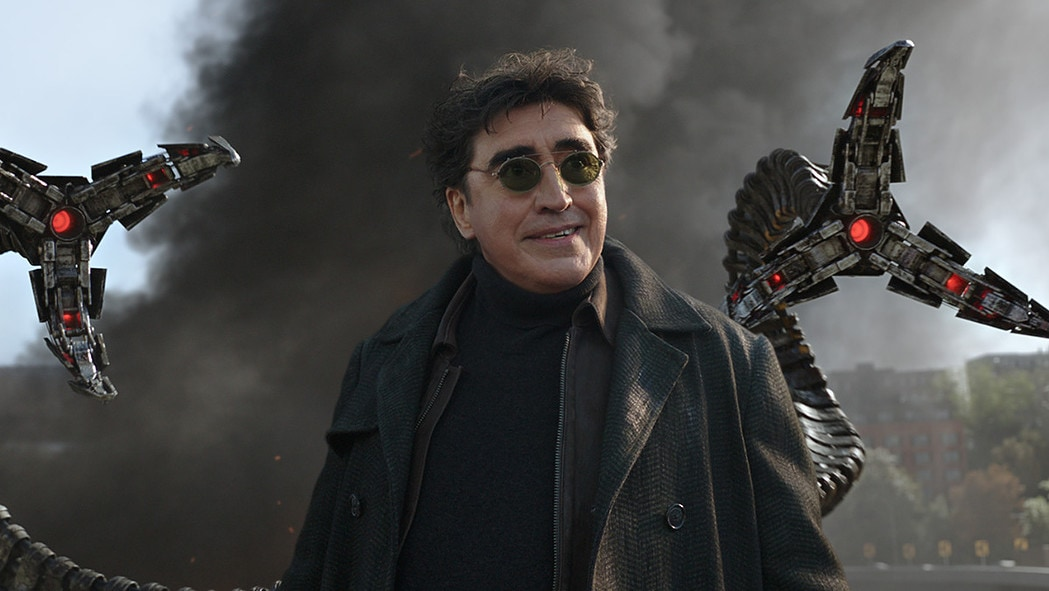Imagine if Doctor Octopus switched to being a hero. What kind of hero might he become? If Doctor Octopus switched sides and became a hero, he would likely use his genius and mechanical mastery for the greater good. As a hero, Doctor Octopus could work towards scientific advancements aimed at benefiting humanity, such as pioneering new medical technologies or developing groundbreaking energy solutions. His mechanical tentacles, once tools of destruction, could become tools for rescue operations and infrastructure building, showcasing his remarkable turnaround and dedication to protecting society. What kind of heroic actions could he perform with his mechanical tentacles? With his mechanical tentacles, Doctor Octopus could perform a range of heroic actions. He could save people from burning buildings by extending his tentacles to reach those trapped on higher floors. In disaster scenarios like earthquakes, his tentacles could clear rubble to rescue survivors. His agility and the strength of his tentacles could allow him to prevent accidents, such as stopping runaway vehicles or catching falling structures. The versatility and strength of his tentacles would make him a powerful ally in any emergency situation, turning his feared appendages into symbols of hope. Describe in detail a moment where Doctor Octopus heroically saves a city from disaster. In an alternate reality, Doctor Octopus, now a hero, springs into action as a massive earthquake strikes a major city. With buildings collapsing and people trapped under debris, he uses his mechanical tentacles to lift massive chunks of rubble, carefully extracting survivors trapped beneath. Moving swiftly through the chaos, his tentacles allow him to reach places inaccessible to ordinary rescue teams. He coordinates with first responders, using his tentacles to stabilize structures on the verge of collapse, preventing further casualties. Near the city's central hospital, he clears pathways for ambulances and sets up makeshift barriers to keep panicked crowds safe. His mechanical appendages work tirelessly, pulling people from precarious heights and ferrying the injured to safety. Throughout the ordeal, Doctor Octopus remains a beacon of hope, his tentacles—once tools of his infamy—now synonymous with salvation, embodying his full commitment to protecting the city and its inhabitants. 